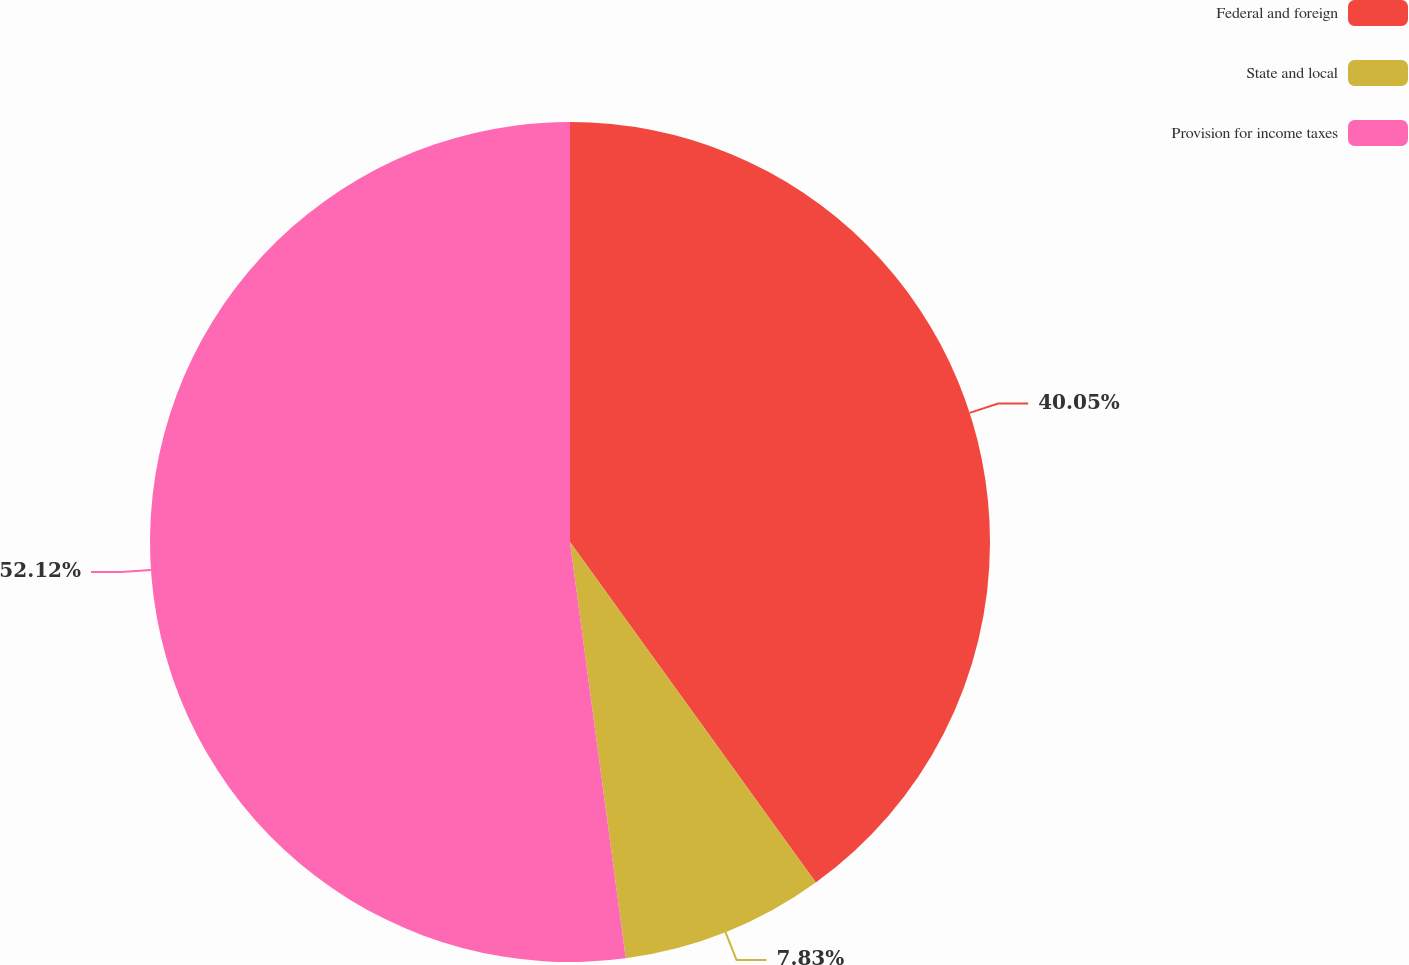Convert chart. <chart><loc_0><loc_0><loc_500><loc_500><pie_chart><fcel>Federal and foreign<fcel>State and local<fcel>Provision for income taxes<nl><fcel>40.05%<fcel>7.83%<fcel>52.12%<nl></chart> 